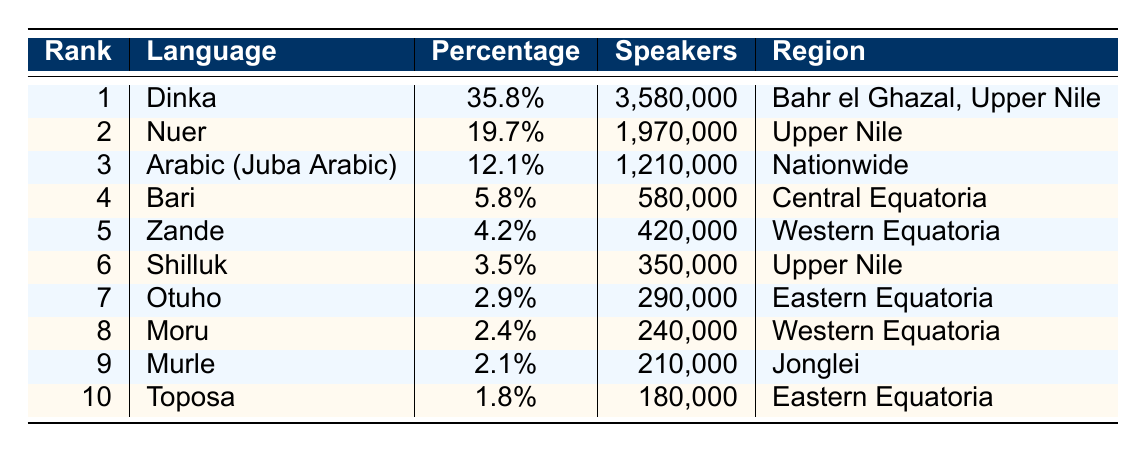What is the most spoken language in South Sudan? The table shows that Dinka has the highest percentage of speakers at 35.8%.
Answer: Dinka How many speakers does the Nuer language have? By looking at the table, Nuer has 1,970,000 speakers listed under the 'Speakers' column.
Answer: 1,970,000 What percentage of the population speaks Arabic (Juba Arabic)? The table indicates that Arabic (Juba Arabic) is spoken by 12.1% of the population.
Answer: 12.1% Which language has the smallest number of speakers in the top 10? The table highlights that Toposa has the smallest number of speakers with 180,000.
Answer: Toposa If you add up the percentage of speakers for the top three languages, what do you get? Adding the percentages: 35.8% (Dinka) + 19.7% (Nuer) + 12.1% (Arabic) equals 67.6%.
Answer: 67.6% Is the Zande language spoken in Eastern Equatoria? The table shows that Zande is spoken in Western Equatoria, not Eastern Equatoria.
Answer: No What is the difference in the number of speakers between Shilluk and Otuho? Shilluk has 350,000 speakers and Otuho has 290,000 speakers. The difference is 350,000 - 290,000 = 60,000.
Answer: 60,000 What is the total number of speakers for the languages listed in the top 10? The total number of speakers is the sum of the speakers for each language: 3,580,000 + 1,970,000 + 1,210,000 + 580,000 + 420,000 + 350,000 + 290,000 + 240,000 + 210,000 + 180,000 = 10,700,000.
Answer: 10,700,000 Which region has the highest proportion of speakers for its language according to the table? Dinka is highlighted as being associated with Bahr el Ghazal and Upper Nile, having the highest percentage of 35.8%, making it the most significant region.
Answer: Bahr el Ghazal, Upper Nile Are there more speakers of Bari or Murle? The table shows Bari has 580,000 speakers and Murle has 210,000 speakers, indicating Bari has more speakers.
Answer: Bari 